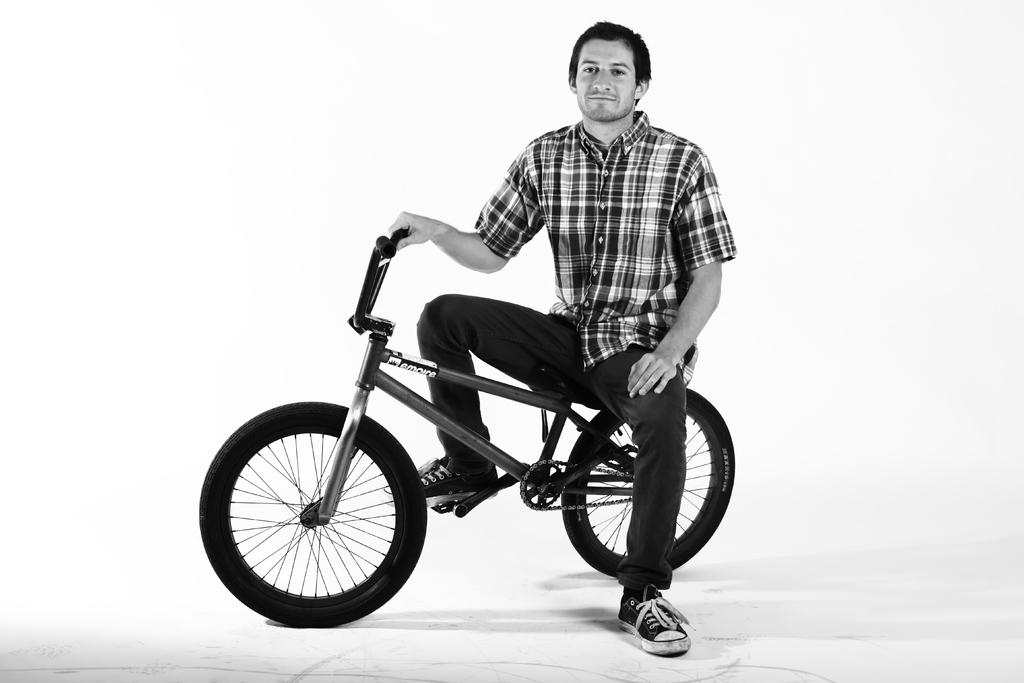What is the color scheme of the image? The image is black and white. Who is present in the image? There is a man in the image. What is the man doing in the image? The man is sitting on a bicycle and holding the handle of the bicycle. What is the man's facial expression in the image? The man is smiling in the image. What type of eggnog is the man drinking in the image? There is no eggnog present in the image; it is a black and white image of a man sitting on a bicycle. What medical procedure is the doctor performing on the man in the image? There is no doctor or medical procedure present in the image; it is a man sitting on a bicycle. 